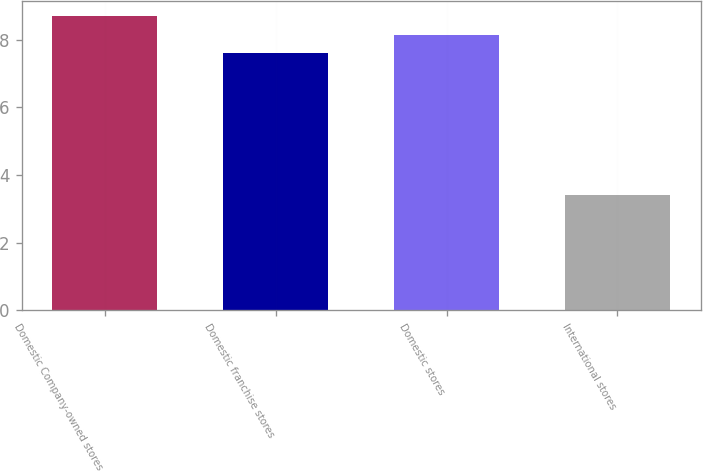Convert chart. <chart><loc_0><loc_0><loc_500><loc_500><bar_chart><fcel>Domestic Company-owned stores<fcel>Domestic franchise stores<fcel>Domestic stores<fcel>International stores<nl><fcel>8.7<fcel>7.6<fcel>8.13<fcel>3.4<nl></chart> 